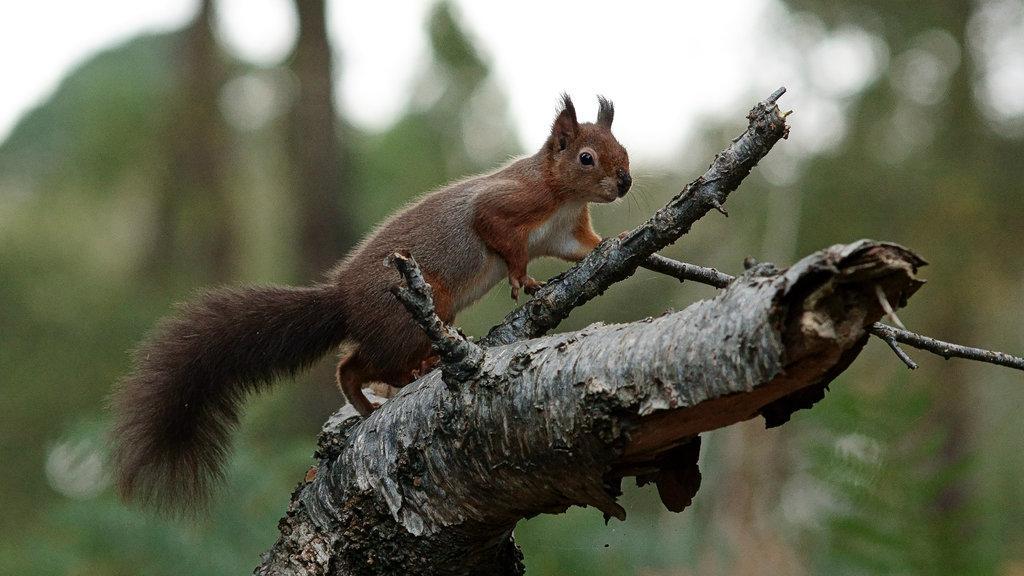How would you summarize this image in a sentence or two? In this image, I can see a squirrel, which is on the tree branch. The background looks blurry. 